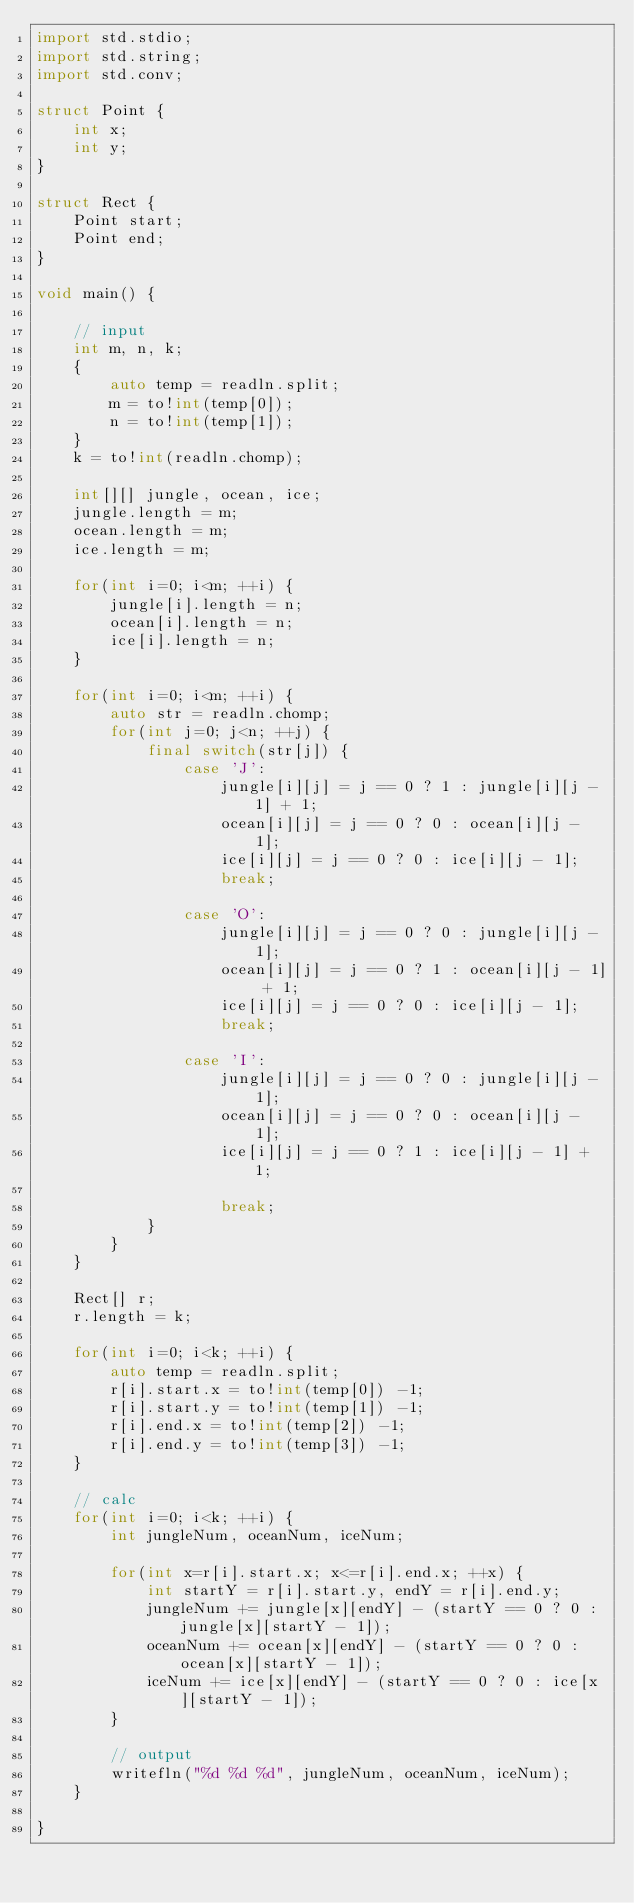Convert code to text. <code><loc_0><loc_0><loc_500><loc_500><_D_>import std.stdio;
import std.string;
import std.conv;

struct Point {
    int x;
    int y;
}

struct Rect {
    Point start;
    Point end;
}

void main() {
    
    // input
    int m, n, k;
    {
        auto temp = readln.split;
        m = to!int(temp[0]);
        n = to!int(temp[1]);
    }
    k = to!int(readln.chomp);
    
    int[][] jungle, ocean, ice;
    jungle.length = m;
    ocean.length = m;
    ice.length = m;
    
    for(int i=0; i<m; ++i) {
        jungle[i].length = n;
        ocean[i].length = n;
        ice[i].length = n;
    }
    
    for(int i=0; i<m; ++i) {
        auto str = readln.chomp;
        for(int j=0; j<n; ++j) {
            final switch(str[j]) {
                case 'J':
                    jungle[i][j] = j == 0 ? 1 : jungle[i][j - 1] + 1;
                    ocean[i][j] = j == 0 ? 0 : ocean[i][j - 1];
                    ice[i][j] = j == 0 ? 0 : ice[i][j - 1];
                    break;
                
                case 'O':
                    jungle[i][j] = j == 0 ? 0 : jungle[i][j - 1];
                    ocean[i][j] = j == 0 ? 1 : ocean[i][j - 1] + 1;
                    ice[i][j] = j == 0 ? 0 : ice[i][j - 1];
                    break;
                
                case 'I':
                    jungle[i][j] = j == 0 ? 0 : jungle[i][j - 1];
                    ocean[i][j] = j == 0 ? 0 : ocean[i][j - 1];
                    ice[i][j] = j == 0 ? 1 : ice[i][j - 1] + 1;

                    break;
            }
        }
    }
    
    Rect[] r;
    r.length = k;
    
    for(int i=0; i<k; ++i) {
        auto temp = readln.split;
        r[i].start.x = to!int(temp[0]) -1;
        r[i].start.y = to!int(temp[1]) -1;
        r[i].end.x = to!int(temp[2]) -1;
        r[i].end.y = to!int(temp[3]) -1;
    }
    
    // calc
    for(int i=0; i<k; ++i) {
        int jungleNum, oceanNum, iceNum;
        
        for(int x=r[i].start.x; x<=r[i].end.x; ++x) {
            int startY = r[i].start.y, endY = r[i].end.y;
            jungleNum += jungle[x][endY] - (startY == 0 ? 0 : jungle[x][startY - 1]);
            oceanNum += ocean[x][endY] - (startY == 0 ? 0 : ocean[x][startY - 1]);
            iceNum += ice[x][endY] - (startY == 0 ? 0 : ice[x][startY - 1]);
        }
        
        // output
        writefln("%d %d %d", jungleNum, oceanNum, iceNum);
    }
    
}</code> 